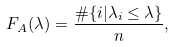<formula> <loc_0><loc_0><loc_500><loc_500>F _ { A } ( \lambda ) = \frac { \# \{ i | \lambda _ { i } \leq \lambda \} } { n } ,</formula> 